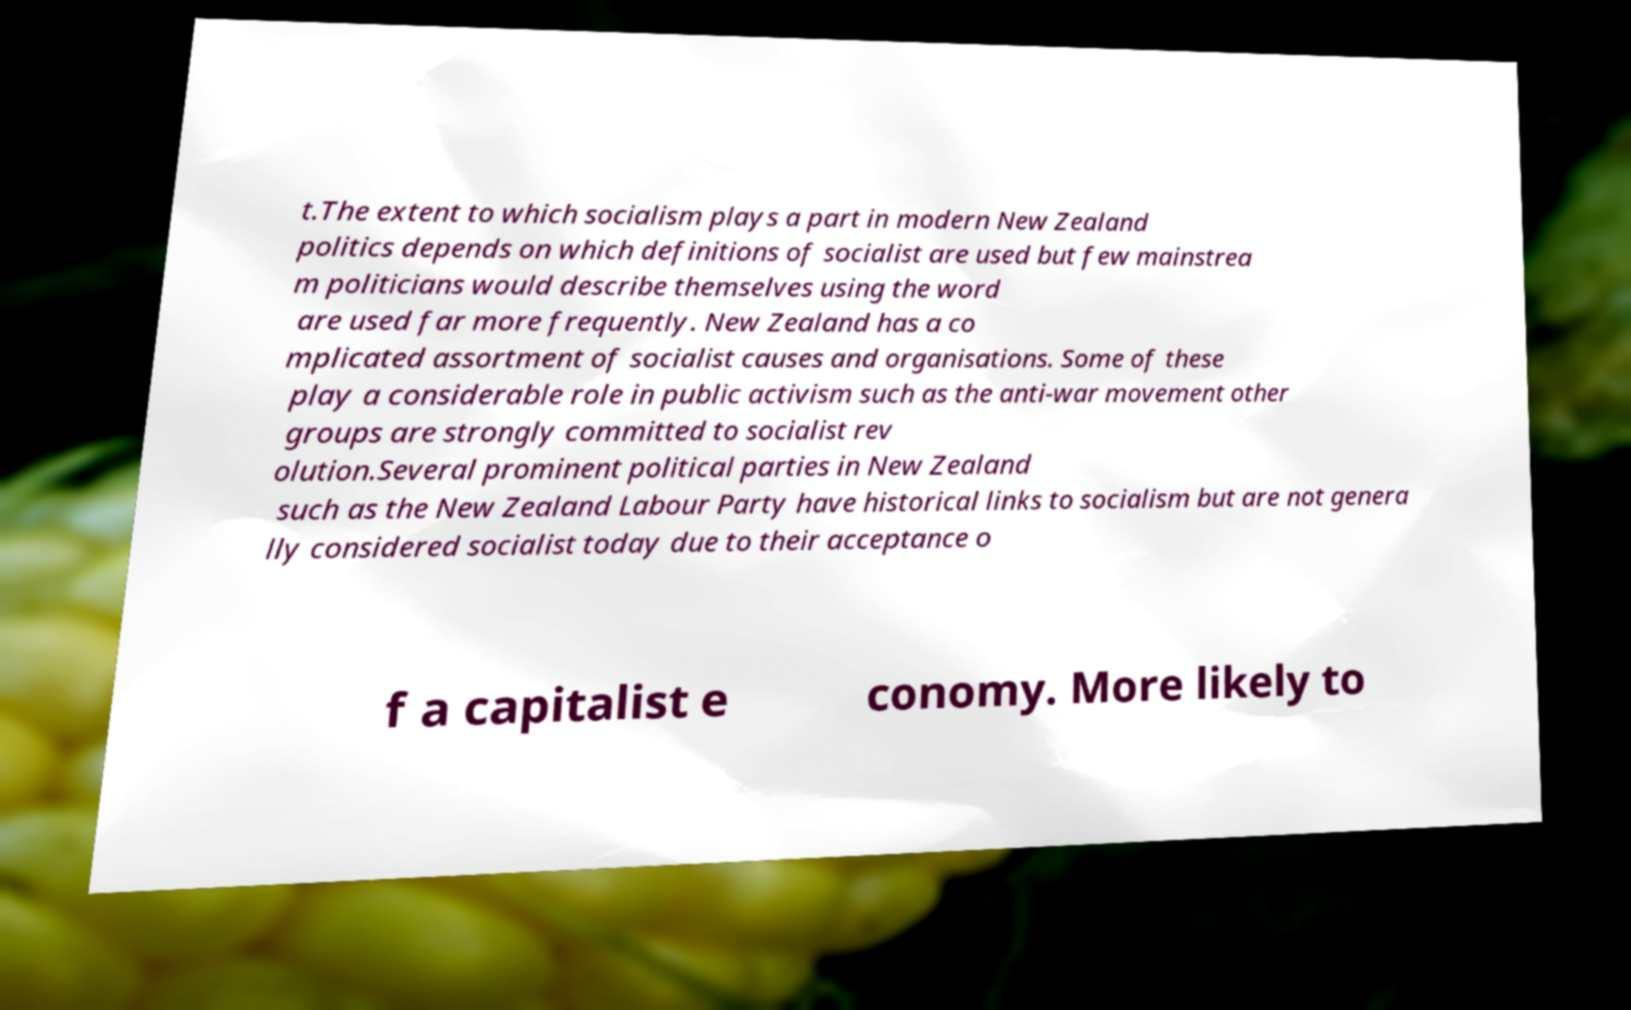Could you assist in decoding the text presented in this image and type it out clearly? t.The extent to which socialism plays a part in modern New Zealand politics depends on which definitions of socialist are used but few mainstrea m politicians would describe themselves using the word are used far more frequently. New Zealand has a co mplicated assortment of socialist causes and organisations. Some of these play a considerable role in public activism such as the anti-war movement other groups are strongly committed to socialist rev olution.Several prominent political parties in New Zealand such as the New Zealand Labour Party have historical links to socialism but are not genera lly considered socialist today due to their acceptance o f a capitalist e conomy. More likely to 